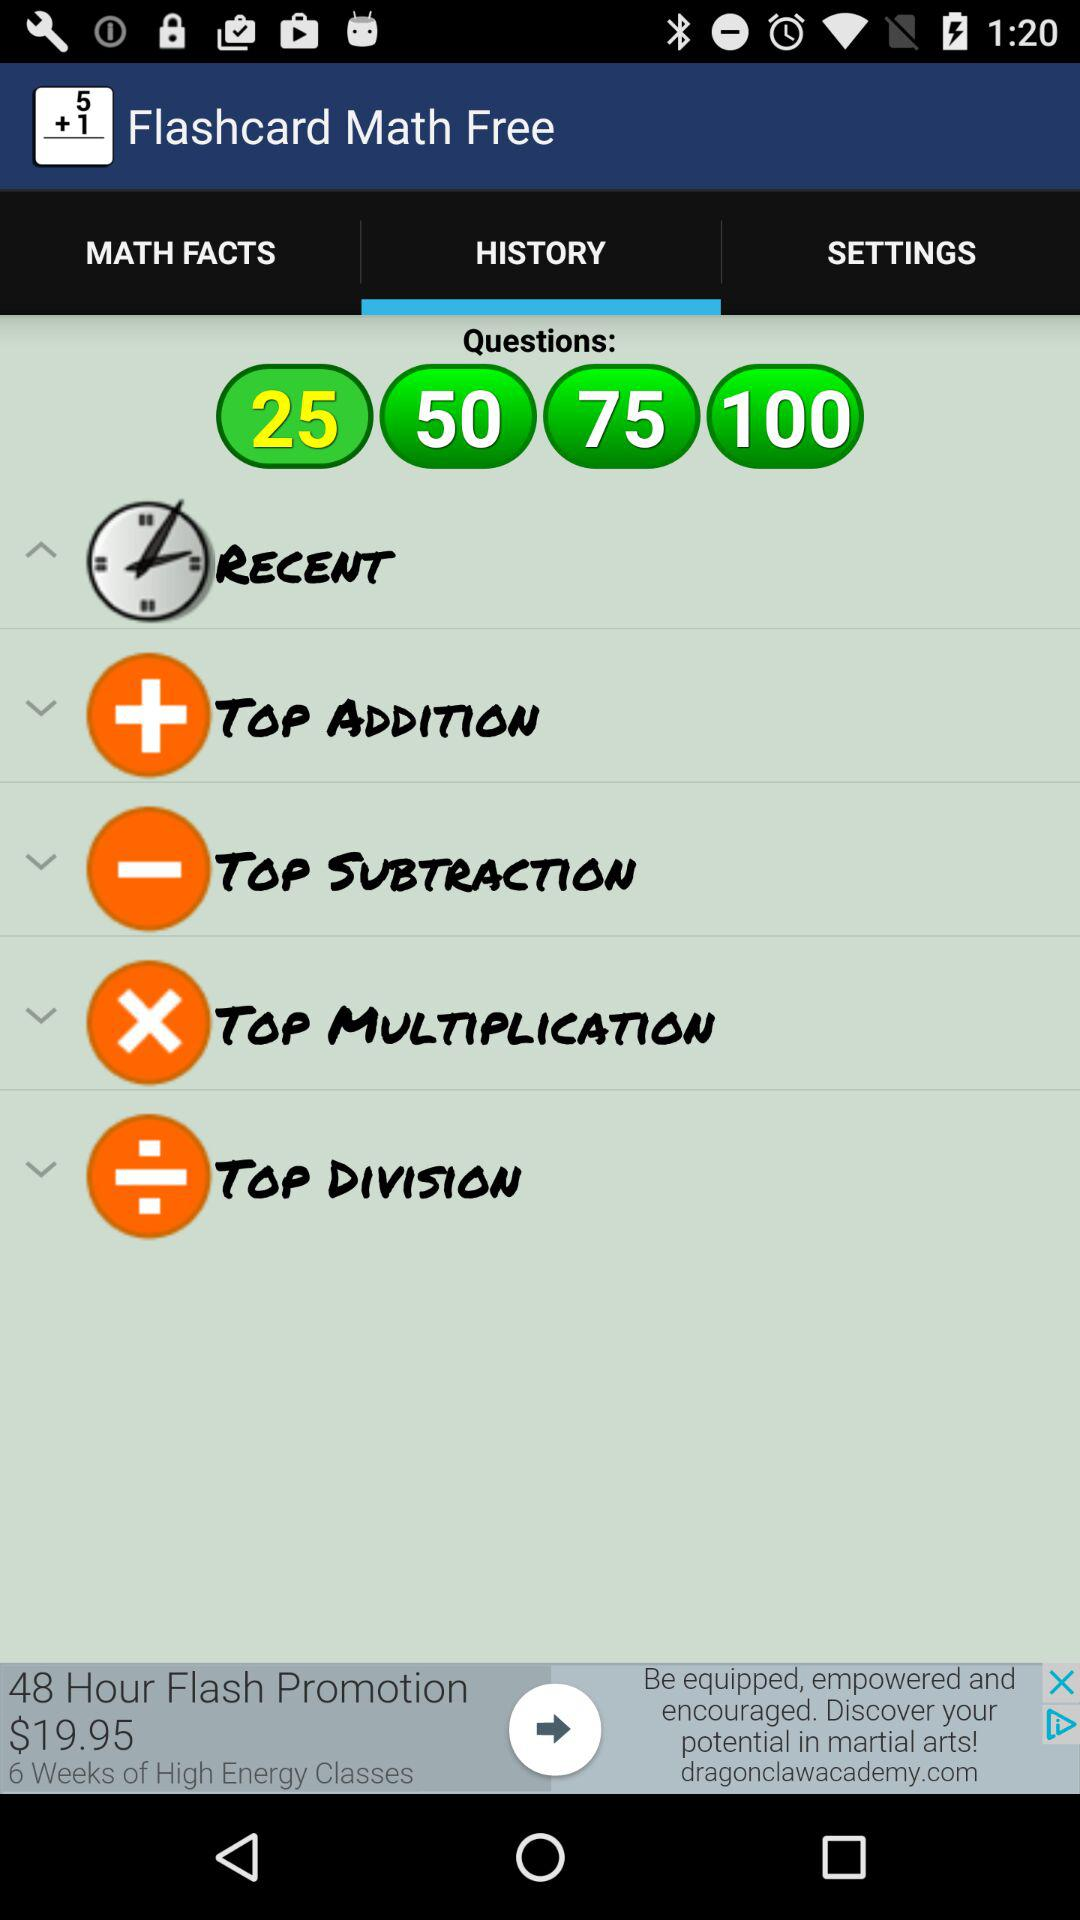What is the application name? The application name is "Flashcard Math Free". 